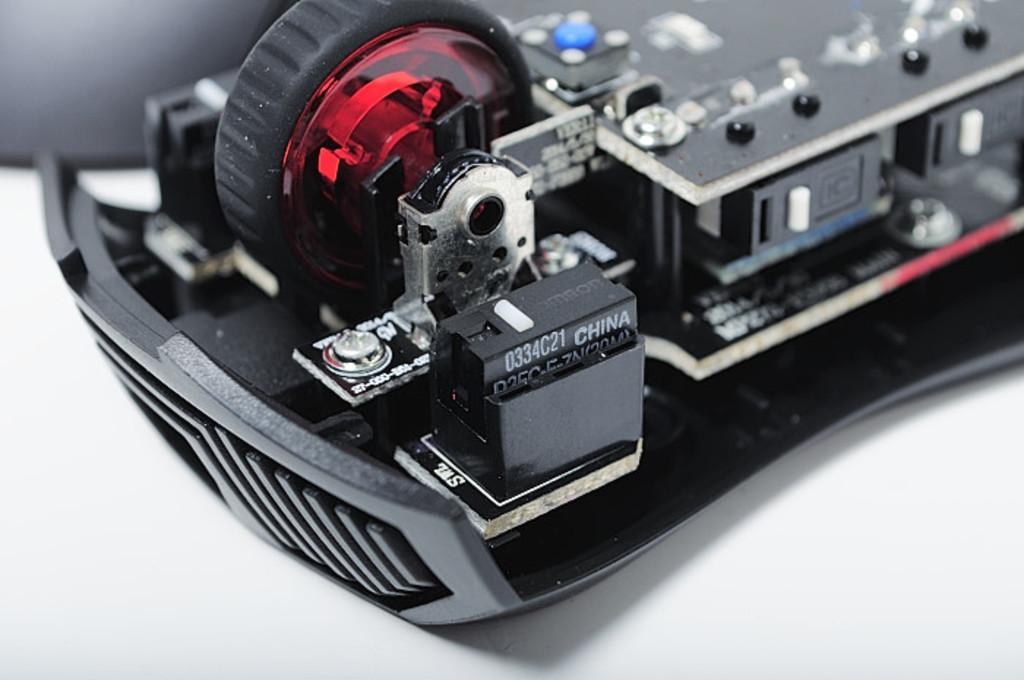How would you summarize this image in a sentence or two? In this image we can see a machine on the white colored surface, there are some texts on it. 